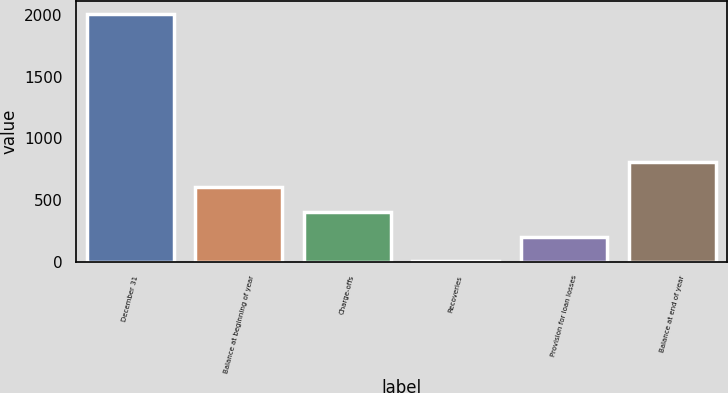Convert chart. <chart><loc_0><loc_0><loc_500><loc_500><bar_chart><fcel>December 31<fcel>Balance at beginning of year<fcel>Charge-offs<fcel>Recoveries<fcel>Provision for loan losses<fcel>Balance at end of year<nl><fcel>2011<fcel>604.7<fcel>403.8<fcel>2<fcel>202.9<fcel>805.6<nl></chart> 